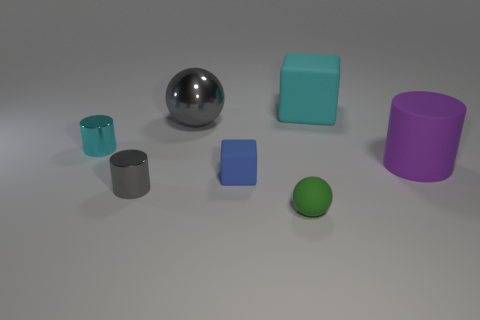Add 3 cyan blocks. How many objects exist? 10 Subtract all cubes. How many objects are left? 5 Subtract 0 purple blocks. How many objects are left? 7 Subtract all tiny red cylinders. Subtract all large objects. How many objects are left? 4 Add 1 blue matte cubes. How many blue matte cubes are left? 2 Add 5 yellow cubes. How many yellow cubes exist? 5 